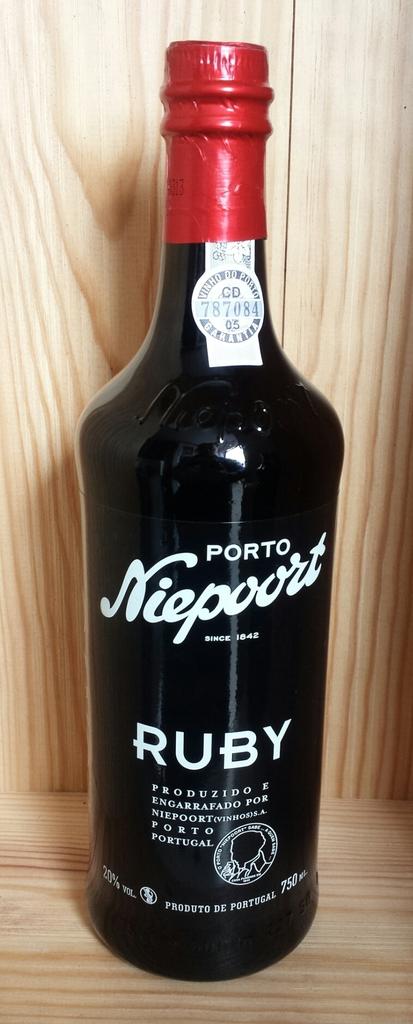What kind of wine is this?
Offer a terse response. Ruby. What are the numbers on the top circle label?
Offer a terse response. 787084. 